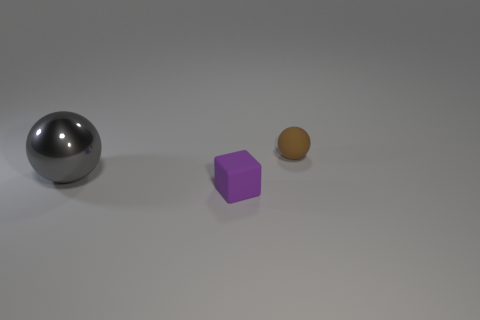Is there anything else that has the same material as the big sphere?
Give a very brief answer. No. How many metallic objects are either big gray cylinders or tiny brown balls?
Offer a very short reply. 0. Is there anything else that is the same size as the purple object?
Offer a terse response. Yes. There is another object that is made of the same material as the purple thing; what color is it?
Keep it short and to the point. Brown. What number of spheres are either green metal objects or brown matte objects?
Offer a terse response. 1. How many objects are small gray metallic balls or objects right of the gray metal sphere?
Provide a succinct answer. 2. Are any brown balls visible?
Give a very brief answer. Yes. How many tiny rubber blocks are the same color as the tiny ball?
Your answer should be compact. 0. What is the size of the ball on the left side of the rubber thing that is in front of the large metal sphere?
Your answer should be very brief. Large. Is there a tiny purple block made of the same material as the brown sphere?
Your answer should be compact. Yes. 